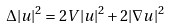Convert formula to latex. <formula><loc_0><loc_0><loc_500><loc_500>\Delta | u | ^ { 2 } = 2 V | u | ^ { 2 } + 2 | \nabla u | ^ { 2 }</formula> 